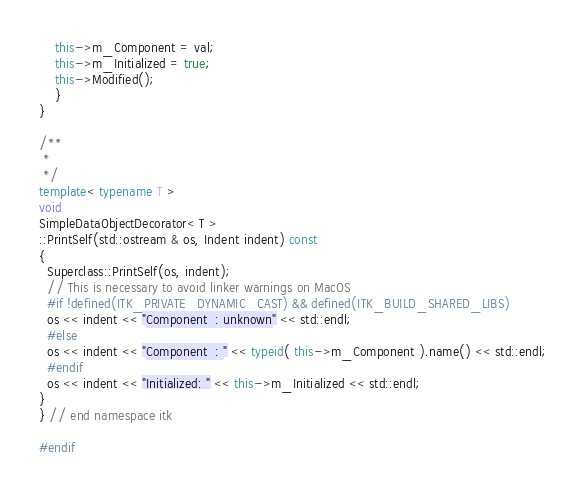<code> <loc_0><loc_0><loc_500><loc_500><_C++_>    this->m_Component = val;
    this->m_Initialized = true;
    this->Modified();
    }
}

/**
 *
 */
template< typename T >
void
SimpleDataObjectDecorator< T >
::PrintSelf(std::ostream & os, Indent indent) const
{
  Superclass::PrintSelf(os, indent);
  // This is necessary to avoid linker warnings on MacOS
  #if !defined(ITK_PRIVATE_DYNAMIC_CAST) && defined(ITK_BUILD_SHARED_LIBS)
  os << indent << "Component  : unknown" << std::endl;
  #else
  os << indent << "Component  : " << typeid( this->m_Component ).name() << std::endl;
  #endif
  os << indent << "Initialized: " << this->m_Initialized << std::endl;
}
} // end namespace itk

#endif
</code> 